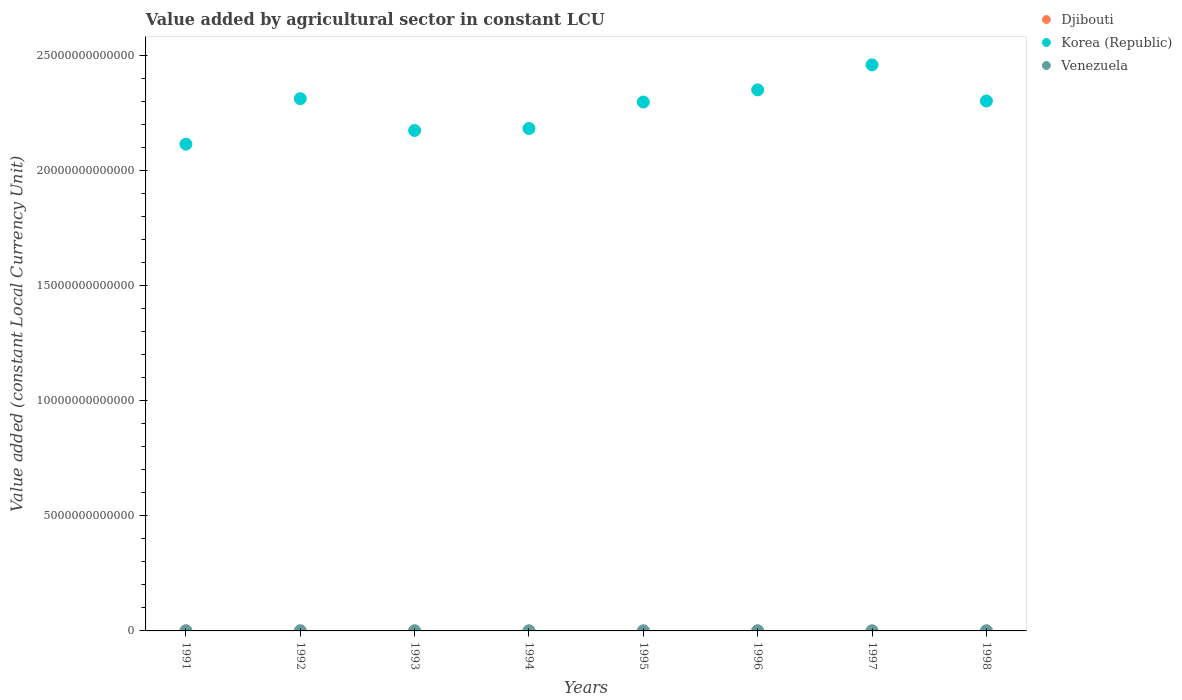Is the number of dotlines equal to the number of legend labels?
Your answer should be very brief. Yes. What is the value added by agricultural sector in Venezuela in 1991?
Provide a succinct answer. 1.82e+09. Across all years, what is the maximum value added by agricultural sector in Korea (Republic)?
Make the answer very short. 2.46e+13. Across all years, what is the minimum value added by agricultural sector in Djibouti?
Offer a very short reply. 1.95e+09. In which year was the value added by agricultural sector in Korea (Republic) maximum?
Provide a short and direct response. 1997. In which year was the value added by agricultural sector in Venezuela minimum?
Offer a terse response. 1991. What is the total value added by agricultural sector in Korea (Republic) in the graph?
Offer a very short reply. 1.82e+14. What is the difference between the value added by agricultural sector in Venezuela in 1995 and that in 1998?
Offer a very short reply. -6.92e+07. What is the difference between the value added by agricultural sector in Djibouti in 1998 and the value added by agricultural sector in Venezuela in 1991?
Offer a terse response. 1.99e+08. What is the average value added by agricultural sector in Venezuela per year?
Provide a short and direct response. 1.89e+09. In the year 1997, what is the difference between the value added by agricultural sector in Korea (Republic) and value added by agricultural sector in Venezuela?
Offer a very short reply. 2.46e+13. In how many years, is the value added by agricultural sector in Venezuela greater than 10000000000000 LCU?
Your response must be concise. 0. What is the ratio of the value added by agricultural sector in Korea (Republic) in 1996 to that in 1997?
Offer a terse response. 0.96. Is the difference between the value added by agricultural sector in Korea (Republic) in 1997 and 1998 greater than the difference between the value added by agricultural sector in Venezuela in 1997 and 1998?
Give a very brief answer. Yes. What is the difference between the highest and the second highest value added by agricultural sector in Djibouti?
Make the answer very short. 2.32e+07. What is the difference between the highest and the lowest value added by agricultural sector in Korea (Republic)?
Offer a very short reply. 3.44e+12. In how many years, is the value added by agricultural sector in Djibouti greater than the average value added by agricultural sector in Djibouti taken over all years?
Make the answer very short. 4. Is the sum of the value added by agricultural sector in Venezuela in 1996 and 1998 greater than the maximum value added by agricultural sector in Djibouti across all years?
Offer a terse response. Yes. Is it the case that in every year, the sum of the value added by agricultural sector in Korea (Republic) and value added by agricultural sector in Venezuela  is greater than the value added by agricultural sector in Djibouti?
Your answer should be compact. Yes. Is the value added by agricultural sector in Venezuela strictly greater than the value added by agricultural sector in Djibouti over the years?
Provide a succinct answer. No. How many dotlines are there?
Your response must be concise. 3. What is the difference between two consecutive major ticks on the Y-axis?
Provide a succinct answer. 5.00e+12. Are the values on the major ticks of Y-axis written in scientific E-notation?
Offer a very short reply. No. Where does the legend appear in the graph?
Your answer should be compact. Top right. How many legend labels are there?
Ensure brevity in your answer.  3. What is the title of the graph?
Offer a terse response. Value added by agricultural sector in constant LCU. Does "French Polynesia" appear as one of the legend labels in the graph?
Your answer should be compact. No. What is the label or title of the Y-axis?
Provide a succinct answer. Value added (constant Local Currency Unit). What is the Value added (constant Local Currency Unit) of Djibouti in 1991?
Your answer should be very brief. 2.14e+09. What is the Value added (constant Local Currency Unit) of Korea (Republic) in 1991?
Your answer should be compact. 2.11e+13. What is the Value added (constant Local Currency Unit) in Venezuela in 1991?
Provide a succinct answer. 1.82e+09. What is the Value added (constant Local Currency Unit) in Djibouti in 1992?
Make the answer very short. 2.23e+09. What is the Value added (constant Local Currency Unit) of Korea (Republic) in 1992?
Keep it short and to the point. 2.31e+13. What is the Value added (constant Local Currency Unit) in Venezuela in 1992?
Give a very brief answer. 1.86e+09. What is the Value added (constant Local Currency Unit) of Djibouti in 1993?
Offer a terse response. 2.25e+09. What is the Value added (constant Local Currency Unit) in Korea (Republic) in 1993?
Make the answer very short. 2.17e+13. What is the Value added (constant Local Currency Unit) in Venezuela in 1993?
Give a very brief answer. 1.91e+09. What is the Value added (constant Local Currency Unit) in Djibouti in 1994?
Your answer should be compact. 2.27e+09. What is the Value added (constant Local Currency Unit) in Korea (Republic) in 1994?
Your answer should be compact. 2.18e+13. What is the Value added (constant Local Currency Unit) of Venezuela in 1994?
Make the answer very short. 1.89e+09. What is the Value added (constant Local Currency Unit) of Djibouti in 1995?
Offer a terse response. 1.95e+09. What is the Value added (constant Local Currency Unit) in Korea (Republic) in 1995?
Your answer should be very brief. 2.30e+13. What is the Value added (constant Local Currency Unit) in Venezuela in 1995?
Give a very brief answer. 1.88e+09. What is the Value added (constant Local Currency Unit) of Djibouti in 1996?
Give a very brief answer. 2.01e+09. What is the Value added (constant Local Currency Unit) in Korea (Republic) in 1996?
Your answer should be very brief. 2.35e+13. What is the Value added (constant Local Currency Unit) of Venezuela in 1996?
Offer a very short reply. 1.92e+09. What is the Value added (constant Local Currency Unit) of Djibouti in 1997?
Your response must be concise. 2.00e+09. What is the Value added (constant Local Currency Unit) of Korea (Republic) in 1997?
Make the answer very short. 2.46e+13. What is the Value added (constant Local Currency Unit) of Venezuela in 1997?
Your answer should be compact. 1.89e+09. What is the Value added (constant Local Currency Unit) of Djibouti in 1998?
Your answer should be compact. 2.02e+09. What is the Value added (constant Local Currency Unit) of Korea (Republic) in 1998?
Make the answer very short. 2.30e+13. What is the Value added (constant Local Currency Unit) in Venezuela in 1998?
Make the answer very short. 1.95e+09. Across all years, what is the maximum Value added (constant Local Currency Unit) in Djibouti?
Offer a terse response. 2.27e+09. Across all years, what is the maximum Value added (constant Local Currency Unit) in Korea (Republic)?
Ensure brevity in your answer.  2.46e+13. Across all years, what is the maximum Value added (constant Local Currency Unit) in Venezuela?
Your answer should be very brief. 1.95e+09. Across all years, what is the minimum Value added (constant Local Currency Unit) of Djibouti?
Offer a terse response. 1.95e+09. Across all years, what is the minimum Value added (constant Local Currency Unit) in Korea (Republic)?
Your response must be concise. 2.11e+13. Across all years, what is the minimum Value added (constant Local Currency Unit) of Venezuela?
Your answer should be compact. 1.82e+09. What is the total Value added (constant Local Currency Unit) of Djibouti in the graph?
Your answer should be very brief. 1.69e+1. What is the total Value added (constant Local Currency Unit) in Korea (Republic) in the graph?
Ensure brevity in your answer.  1.82e+14. What is the total Value added (constant Local Currency Unit) of Venezuela in the graph?
Your answer should be compact. 1.51e+1. What is the difference between the Value added (constant Local Currency Unit) of Djibouti in 1991 and that in 1992?
Ensure brevity in your answer.  -8.37e+07. What is the difference between the Value added (constant Local Currency Unit) in Korea (Republic) in 1991 and that in 1992?
Offer a terse response. -1.98e+12. What is the difference between the Value added (constant Local Currency Unit) in Venezuela in 1991 and that in 1992?
Your answer should be compact. -3.68e+07. What is the difference between the Value added (constant Local Currency Unit) of Djibouti in 1991 and that in 1993?
Provide a succinct answer. -1.07e+08. What is the difference between the Value added (constant Local Currency Unit) of Korea (Republic) in 1991 and that in 1993?
Make the answer very short. -5.94e+11. What is the difference between the Value added (constant Local Currency Unit) of Venezuela in 1991 and that in 1993?
Your response must be concise. -9.30e+07. What is the difference between the Value added (constant Local Currency Unit) of Djibouti in 1991 and that in 1994?
Your answer should be very brief. -1.30e+08. What is the difference between the Value added (constant Local Currency Unit) in Korea (Republic) in 1991 and that in 1994?
Your answer should be very brief. -6.80e+11. What is the difference between the Value added (constant Local Currency Unit) of Venezuela in 1991 and that in 1994?
Your answer should be very brief. -7.19e+07. What is the difference between the Value added (constant Local Currency Unit) of Djibouti in 1991 and that in 1995?
Offer a very short reply. 1.98e+08. What is the difference between the Value added (constant Local Currency Unit) in Korea (Republic) in 1991 and that in 1995?
Offer a very short reply. -1.83e+12. What is the difference between the Value added (constant Local Currency Unit) of Venezuela in 1991 and that in 1995?
Keep it short and to the point. -6.16e+07. What is the difference between the Value added (constant Local Currency Unit) of Djibouti in 1991 and that in 1996?
Offer a terse response. 1.32e+08. What is the difference between the Value added (constant Local Currency Unit) in Korea (Republic) in 1991 and that in 1996?
Ensure brevity in your answer.  -2.36e+12. What is the difference between the Value added (constant Local Currency Unit) in Venezuela in 1991 and that in 1996?
Offer a very short reply. -9.87e+07. What is the difference between the Value added (constant Local Currency Unit) in Djibouti in 1991 and that in 1997?
Offer a terse response. 1.39e+08. What is the difference between the Value added (constant Local Currency Unit) of Korea (Republic) in 1991 and that in 1997?
Keep it short and to the point. -3.44e+12. What is the difference between the Value added (constant Local Currency Unit) in Venezuela in 1991 and that in 1997?
Your answer should be very brief. -6.49e+07. What is the difference between the Value added (constant Local Currency Unit) of Djibouti in 1991 and that in 1998?
Your answer should be very brief. 1.24e+08. What is the difference between the Value added (constant Local Currency Unit) of Korea (Republic) in 1991 and that in 1998?
Your answer should be compact. -1.88e+12. What is the difference between the Value added (constant Local Currency Unit) in Venezuela in 1991 and that in 1998?
Provide a succinct answer. -1.31e+08. What is the difference between the Value added (constant Local Currency Unit) in Djibouti in 1992 and that in 1993?
Offer a terse response. -2.35e+07. What is the difference between the Value added (constant Local Currency Unit) of Korea (Republic) in 1992 and that in 1993?
Your response must be concise. 1.38e+12. What is the difference between the Value added (constant Local Currency Unit) of Venezuela in 1992 and that in 1993?
Your answer should be very brief. -5.62e+07. What is the difference between the Value added (constant Local Currency Unit) in Djibouti in 1992 and that in 1994?
Give a very brief answer. -4.67e+07. What is the difference between the Value added (constant Local Currency Unit) in Korea (Republic) in 1992 and that in 1994?
Your response must be concise. 1.29e+12. What is the difference between the Value added (constant Local Currency Unit) in Venezuela in 1992 and that in 1994?
Your answer should be very brief. -3.51e+07. What is the difference between the Value added (constant Local Currency Unit) in Djibouti in 1992 and that in 1995?
Ensure brevity in your answer.  2.81e+08. What is the difference between the Value added (constant Local Currency Unit) in Korea (Republic) in 1992 and that in 1995?
Give a very brief answer. 1.46e+11. What is the difference between the Value added (constant Local Currency Unit) in Venezuela in 1992 and that in 1995?
Your response must be concise. -2.48e+07. What is the difference between the Value added (constant Local Currency Unit) of Djibouti in 1992 and that in 1996?
Keep it short and to the point. 2.16e+08. What is the difference between the Value added (constant Local Currency Unit) of Korea (Republic) in 1992 and that in 1996?
Your answer should be very brief. -3.83e+11. What is the difference between the Value added (constant Local Currency Unit) of Venezuela in 1992 and that in 1996?
Provide a succinct answer. -6.18e+07. What is the difference between the Value added (constant Local Currency Unit) in Djibouti in 1992 and that in 1997?
Your response must be concise. 2.23e+08. What is the difference between the Value added (constant Local Currency Unit) in Korea (Republic) in 1992 and that in 1997?
Give a very brief answer. -1.47e+12. What is the difference between the Value added (constant Local Currency Unit) in Venezuela in 1992 and that in 1997?
Keep it short and to the point. -2.81e+07. What is the difference between the Value added (constant Local Currency Unit) in Djibouti in 1992 and that in 1998?
Your answer should be very brief. 2.08e+08. What is the difference between the Value added (constant Local Currency Unit) of Korea (Republic) in 1992 and that in 1998?
Provide a succinct answer. 1.00e+11. What is the difference between the Value added (constant Local Currency Unit) in Venezuela in 1992 and that in 1998?
Make the answer very short. -9.40e+07. What is the difference between the Value added (constant Local Currency Unit) in Djibouti in 1993 and that in 1994?
Offer a terse response. -2.32e+07. What is the difference between the Value added (constant Local Currency Unit) of Korea (Republic) in 1993 and that in 1994?
Offer a very short reply. -8.64e+1. What is the difference between the Value added (constant Local Currency Unit) in Venezuela in 1993 and that in 1994?
Your answer should be compact. 2.11e+07. What is the difference between the Value added (constant Local Currency Unit) in Djibouti in 1993 and that in 1995?
Give a very brief answer. 3.05e+08. What is the difference between the Value added (constant Local Currency Unit) in Korea (Republic) in 1993 and that in 1995?
Offer a terse response. -1.24e+12. What is the difference between the Value added (constant Local Currency Unit) of Venezuela in 1993 and that in 1995?
Keep it short and to the point. 3.14e+07. What is the difference between the Value added (constant Local Currency Unit) in Djibouti in 1993 and that in 1996?
Your response must be concise. 2.40e+08. What is the difference between the Value added (constant Local Currency Unit) of Korea (Republic) in 1993 and that in 1996?
Provide a succinct answer. -1.76e+12. What is the difference between the Value added (constant Local Currency Unit) in Venezuela in 1993 and that in 1996?
Offer a terse response. -5.65e+06. What is the difference between the Value added (constant Local Currency Unit) of Djibouti in 1993 and that in 1997?
Your response must be concise. 2.47e+08. What is the difference between the Value added (constant Local Currency Unit) in Korea (Republic) in 1993 and that in 1997?
Give a very brief answer. -2.85e+12. What is the difference between the Value added (constant Local Currency Unit) of Venezuela in 1993 and that in 1997?
Provide a succinct answer. 2.81e+07. What is the difference between the Value added (constant Local Currency Unit) in Djibouti in 1993 and that in 1998?
Give a very brief answer. 2.31e+08. What is the difference between the Value added (constant Local Currency Unit) in Korea (Republic) in 1993 and that in 1998?
Make the answer very short. -1.28e+12. What is the difference between the Value added (constant Local Currency Unit) of Venezuela in 1993 and that in 1998?
Give a very brief answer. -3.78e+07. What is the difference between the Value added (constant Local Currency Unit) in Djibouti in 1994 and that in 1995?
Ensure brevity in your answer.  3.28e+08. What is the difference between the Value added (constant Local Currency Unit) in Korea (Republic) in 1994 and that in 1995?
Your answer should be very brief. -1.15e+12. What is the difference between the Value added (constant Local Currency Unit) of Venezuela in 1994 and that in 1995?
Offer a very short reply. 1.02e+07. What is the difference between the Value added (constant Local Currency Unit) of Djibouti in 1994 and that in 1996?
Your response must be concise. 2.63e+08. What is the difference between the Value added (constant Local Currency Unit) of Korea (Republic) in 1994 and that in 1996?
Give a very brief answer. -1.68e+12. What is the difference between the Value added (constant Local Currency Unit) of Venezuela in 1994 and that in 1996?
Your answer should be very brief. -2.68e+07. What is the difference between the Value added (constant Local Currency Unit) of Djibouti in 1994 and that in 1997?
Offer a very short reply. 2.70e+08. What is the difference between the Value added (constant Local Currency Unit) of Korea (Republic) in 1994 and that in 1997?
Your answer should be very brief. -2.76e+12. What is the difference between the Value added (constant Local Currency Unit) of Venezuela in 1994 and that in 1997?
Keep it short and to the point. 6.98e+06. What is the difference between the Value added (constant Local Currency Unit) of Djibouti in 1994 and that in 1998?
Ensure brevity in your answer.  2.54e+08. What is the difference between the Value added (constant Local Currency Unit) of Korea (Republic) in 1994 and that in 1998?
Provide a succinct answer. -1.19e+12. What is the difference between the Value added (constant Local Currency Unit) of Venezuela in 1994 and that in 1998?
Give a very brief answer. -5.89e+07. What is the difference between the Value added (constant Local Currency Unit) of Djibouti in 1995 and that in 1996?
Your answer should be very brief. -6.52e+07. What is the difference between the Value added (constant Local Currency Unit) of Korea (Republic) in 1995 and that in 1996?
Make the answer very short. -5.29e+11. What is the difference between the Value added (constant Local Currency Unit) in Venezuela in 1995 and that in 1996?
Provide a short and direct response. -3.70e+07. What is the difference between the Value added (constant Local Currency Unit) of Djibouti in 1995 and that in 1997?
Provide a short and direct response. -5.82e+07. What is the difference between the Value added (constant Local Currency Unit) of Korea (Republic) in 1995 and that in 1997?
Your response must be concise. -1.61e+12. What is the difference between the Value added (constant Local Currency Unit) of Venezuela in 1995 and that in 1997?
Ensure brevity in your answer.  -3.27e+06. What is the difference between the Value added (constant Local Currency Unit) of Djibouti in 1995 and that in 1998?
Keep it short and to the point. -7.37e+07. What is the difference between the Value added (constant Local Currency Unit) in Korea (Republic) in 1995 and that in 1998?
Keep it short and to the point. -4.61e+1. What is the difference between the Value added (constant Local Currency Unit) in Venezuela in 1995 and that in 1998?
Provide a short and direct response. -6.92e+07. What is the difference between the Value added (constant Local Currency Unit) in Djibouti in 1996 and that in 1997?
Give a very brief answer. 7.01e+06. What is the difference between the Value added (constant Local Currency Unit) of Korea (Republic) in 1996 and that in 1997?
Offer a terse response. -1.09e+12. What is the difference between the Value added (constant Local Currency Unit) in Venezuela in 1996 and that in 1997?
Provide a short and direct response. 3.38e+07. What is the difference between the Value added (constant Local Currency Unit) of Djibouti in 1996 and that in 1998?
Your answer should be compact. -8.45e+06. What is the difference between the Value added (constant Local Currency Unit) of Korea (Republic) in 1996 and that in 1998?
Make the answer very short. 4.83e+11. What is the difference between the Value added (constant Local Currency Unit) in Venezuela in 1996 and that in 1998?
Make the answer very short. -3.22e+07. What is the difference between the Value added (constant Local Currency Unit) of Djibouti in 1997 and that in 1998?
Provide a succinct answer. -1.55e+07. What is the difference between the Value added (constant Local Currency Unit) in Korea (Republic) in 1997 and that in 1998?
Provide a succinct answer. 1.57e+12. What is the difference between the Value added (constant Local Currency Unit) of Venezuela in 1997 and that in 1998?
Offer a very short reply. -6.59e+07. What is the difference between the Value added (constant Local Currency Unit) of Djibouti in 1991 and the Value added (constant Local Currency Unit) of Korea (Republic) in 1992?
Keep it short and to the point. -2.31e+13. What is the difference between the Value added (constant Local Currency Unit) in Djibouti in 1991 and the Value added (constant Local Currency Unit) in Venezuela in 1992?
Provide a succinct answer. 2.87e+08. What is the difference between the Value added (constant Local Currency Unit) of Korea (Republic) in 1991 and the Value added (constant Local Currency Unit) of Venezuela in 1992?
Give a very brief answer. 2.11e+13. What is the difference between the Value added (constant Local Currency Unit) in Djibouti in 1991 and the Value added (constant Local Currency Unit) in Korea (Republic) in 1993?
Make the answer very short. -2.17e+13. What is the difference between the Value added (constant Local Currency Unit) of Djibouti in 1991 and the Value added (constant Local Currency Unit) of Venezuela in 1993?
Give a very brief answer. 2.30e+08. What is the difference between the Value added (constant Local Currency Unit) of Korea (Republic) in 1991 and the Value added (constant Local Currency Unit) of Venezuela in 1993?
Your answer should be compact. 2.11e+13. What is the difference between the Value added (constant Local Currency Unit) in Djibouti in 1991 and the Value added (constant Local Currency Unit) in Korea (Republic) in 1994?
Provide a short and direct response. -2.18e+13. What is the difference between the Value added (constant Local Currency Unit) in Djibouti in 1991 and the Value added (constant Local Currency Unit) in Venezuela in 1994?
Provide a succinct answer. 2.51e+08. What is the difference between the Value added (constant Local Currency Unit) of Korea (Republic) in 1991 and the Value added (constant Local Currency Unit) of Venezuela in 1994?
Offer a very short reply. 2.11e+13. What is the difference between the Value added (constant Local Currency Unit) of Djibouti in 1991 and the Value added (constant Local Currency Unit) of Korea (Republic) in 1995?
Provide a short and direct response. -2.30e+13. What is the difference between the Value added (constant Local Currency Unit) of Djibouti in 1991 and the Value added (constant Local Currency Unit) of Venezuela in 1995?
Offer a very short reply. 2.62e+08. What is the difference between the Value added (constant Local Currency Unit) of Korea (Republic) in 1991 and the Value added (constant Local Currency Unit) of Venezuela in 1995?
Keep it short and to the point. 2.11e+13. What is the difference between the Value added (constant Local Currency Unit) of Djibouti in 1991 and the Value added (constant Local Currency Unit) of Korea (Republic) in 1996?
Make the answer very short. -2.35e+13. What is the difference between the Value added (constant Local Currency Unit) in Djibouti in 1991 and the Value added (constant Local Currency Unit) in Venezuela in 1996?
Ensure brevity in your answer.  2.25e+08. What is the difference between the Value added (constant Local Currency Unit) of Korea (Republic) in 1991 and the Value added (constant Local Currency Unit) of Venezuela in 1996?
Your answer should be very brief. 2.11e+13. What is the difference between the Value added (constant Local Currency Unit) in Djibouti in 1991 and the Value added (constant Local Currency Unit) in Korea (Republic) in 1997?
Provide a short and direct response. -2.46e+13. What is the difference between the Value added (constant Local Currency Unit) of Djibouti in 1991 and the Value added (constant Local Currency Unit) of Venezuela in 1997?
Ensure brevity in your answer.  2.58e+08. What is the difference between the Value added (constant Local Currency Unit) in Korea (Republic) in 1991 and the Value added (constant Local Currency Unit) in Venezuela in 1997?
Give a very brief answer. 2.11e+13. What is the difference between the Value added (constant Local Currency Unit) of Djibouti in 1991 and the Value added (constant Local Currency Unit) of Korea (Republic) in 1998?
Your response must be concise. -2.30e+13. What is the difference between the Value added (constant Local Currency Unit) in Djibouti in 1991 and the Value added (constant Local Currency Unit) in Venezuela in 1998?
Provide a short and direct response. 1.93e+08. What is the difference between the Value added (constant Local Currency Unit) in Korea (Republic) in 1991 and the Value added (constant Local Currency Unit) in Venezuela in 1998?
Your response must be concise. 2.11e+13. What is the difference between the Value added (constant Local Currency Unit) of Djibouti in 1992 and the Value added (constant Local Currency Unit) of Korea (Republic) in 1993?
Make the answer very short. -2.17e+13. What is the difference between the Value added (constant Local Currency Unit) of Djibouti in 1992 and the Value added (constant Local Currency Unit) of Venezuela in 1993?
Give a very brief answer. 3.14e+08. What is the difference between the Value added (constant Local Currency Unit) in Korea (Republic) in 1992 and the Value added (constant Local Currency Unit) in Venezuela in 1993?
Make the answer very short. 2.31e+13. What is the difference between the Value added (constant Local Currency Unit) in Djibouti in 1992 and the Value added (constant Local Currency Unit) in Korea (Republic) in 1994?
Give a very brief answer. -2.18e+13. What is the difference between the Value added (constant Local Currency Unit) in Djibouti in 1992 and the Value added (constant Local Currency Unit) in Venezuela in 1994?
Provide a short and direct response. 3.35e+08. What is the difference between the Value added (constant Local Currency Unit) in Korea (Republic) in 1992 and the Value added (constant Local Currency Unit) in Venezuela in 1994?
Ensure brevity in your answer.  2.31e+13. What is the difference between the Value added (constant Local Currency Unit) in Djibouti in 1992 and the Value added (constant Local Currency Unit) in Korea (Republic) in 1995?
Your answer should be very brief. -2.30e+13. What is the difference between the Value added (constant Local Currency Unit) of Djibouti in 1992 and the Value added (constant Local Currency Unit) of Venezuela in 1995?
Ensure brevity in your answer.  3.45e+08. What is the difference between the Value added (constant Local Currency Unit) in Korea (Republic) in 1992 and the Value added (constant Local Currency Unit) in Venezuela in 1995?
Your answer should be very brief. 2.31e+13. What is the difference between the Value added (constant Local Currency Unit) in Djibouti in 1992 and the Value added (constant Local Currency Unit) in Korea (Republic) in 1996?
Give a very brief answer. -2.35e+13. What is the difference between the Value added (constant Local Currency Unit) in Djibouti in 1992 and the Value added (constant Local Currency Unit) in Venezuela in 1996?
Offer a terse response. 3.08e+08. What is the difference between the Value added (constant Local Currency Unit) of Korea (Republic) in 1992 and the Value added (constant Local Currency Unit) of Venezuela in 1996?
Provide a succinct answer. 2.31e+13. What is the difference between the Value added (constant Local Currency Unit) of Djibouti in 1992 and the Value added (constant Local Currency Unit) of Korea (Republic) in 1997?
Provide a short and direct response. -2.46e+13. What is the difference between the Value added (constant Local Currency Unit) of Djibouti in 1992 and the Value added (constant Local Currency Unit) of Venezuela in 1997?
Give a very brief answer. 3.42e+08. What is the difference between the Value added (constant Local Currency Unit) of Korea (Republic) in 1992 and the Value added (constant Local Currency Unit) of Venezuela in 1997?
Provide a short and direct response. 2.31e+13. What is the difference between the Value added (constant Local Currency Unit) of Djibouti in 1992 and the Value added (constant Local Currency Unit) of Korea (Republic) in 1998?
Give a very brief answer. -2.30e+13. What is the difference between the Value added (constant Local Currency Unit) in Djibouti in 1992 and the Value added (constant Local Currency Unit) in Venezuela in 1998?
Your response must be concise. 2.76e+08. What is the difference between the Value added (constant Local Currency Unit) in Korea (Republic) in 1992 and the Value added (constant Local Currency Unit) in Venezuela in 1998?
Your answer should be compact. 2.31e+13. What is the difference between the Value added (constant Local Currency Unit) of Djibouti in 1993 and the Value added (constant Local Currency Unit) of Korea (Republic) in 1994?
Your answer should be compact. -2.18e+13. What is the difference between the Value added (constant Local Currency Unit) of Djibouti in 1993 and the Value added (constant Local Currency Unit) of Venezuela in 1994?
Your answer should be compact. 3.59e+08. What is the difference between the Value added (constant Local Currency Unit) of Korea (Republic) in 1993 and the Value added (constant Local Currency Unit) of Venezuela in 1994?
Provide a succinct answer. 2.17e+13. What is the difference between the Value added (constant Local Currency Unit) of Djibouti in 1993 and the Value added (constant Local Currency Unit) of Korea (Republic) in 1995?
Make the answer very short. -2.30e+13. What is the difference between the Value added (constant Local Currency Unit) of Djibouti in 1993 and the Value added (constant Local Currency Unit) of Venezuela in 1995?
Give a very brief answer. 3.69e+08. What is the difference between the Value added (constant Local Currency Unit) of Korea (Republic) in 1993 and the Value added (constant Local Currency Unit) of Venezuela in 1995?
Offer a terse response. 2.17e+13. What is the difference between the Value added (constant Local Currency Unit) in Djibouti in 1993 and the Value added (constant Local Currency Unit) in Korea (Republic) in 1996?
Provide a short and direct response. -2.35e+13. What is the difference between the Value added (constant Local Currency Unit) in Djibouti in 1993 and the Value added (constant Local Currency Unit) in Venezuela in 1996?
Give a very brief answer. 3.32e+08. What is the difference between the Value added (constant Local Currency Unit) of Korea (Republic) in 1993 and the Value added (constant Local Currency Unit) of Venezuela in 1996?
Offer a terse response. 2.17e+13. What is the difference between the Value added (constant Local Currency Unit) in Djibouti in 1993 and the Value added (constant Local Currency Unit) in Korea (Republic) in 1997?
Provide a succinct answer. -2.46e+13. What is the difference between the Value added (constant Local Currency Unit) of Djibouti in 1993 and the Value added (constant Local Currency Unit) of Venezuela in 1997?
Offer a terse response. 3.66e+08. What is the difference between the Value added (constant Local Currency Unit) in Korea (Republic) in 1993 and the Value added (constant Local Currency Unit) in Venezuela in 1997?
Your answer should be very brief. 2.17e+13. What is the difference between the Value added (constant Local Currency Unit) in Djibouti in 1993 and the Value added (constant Local Currency Unit) in Korea (Republic) in 1998?
Give a very brief answer. -2.30e+13. What is the difference between the Value added (constant Local Currency Unit) of Djibouti in 1993 and the Value added (constant Local Currency Unit) of Venezuela in 1998?
Give a very brief answer. 3.00e+08. What is the difference between the Value added (constant Local Currency Unit) in Korea (Republic) in 1993 and the Value added (constant Local Currency Unit) in Venezuela in 1998?
Provide a short and direct response. 2.17e+13. What is the difference between the Value added (constant Local Currency Unit) of Djibouti in 1994 and the Value added (constant Local Currency Unit) of Korea (Republic) in 1995?
Give a very brief answer. -2.30e+13. What is the difference between the Value added (constant Local Currency Unit) of Djibouti in 1994 and the Value added (constant Local Currency Unit) of Venezuela in 1995?
Your response must be concise. 3.92e+08. What is the difference between the Value added (constant Local Currency Unit) of Korea (Republic) in 1994 and the Value added (constant Local Currency Unit) of Venezuela in 1995?
Offer a very short reply. 2.18e+13. What is the difference between the Value added (constant Local Currency Unit) of Djibouti in 1994 and the Value added (constant Local Currency Unit) of Korea (Republic) in 1996?
Your answer should be very brief. -2.35e+13. What is the difference between the Value added (constant Local Currency Unit) in Djibouti in 1994 and the Value added (constant Local Currency Unit) in Venezuela in 1996?
Make the answer very short. 3.55e+08. What is the difference between the Value added (constant Local Currency Unit) of Korea (Republic) in 1994 and the Value added (constant Local Currency Unit) of Venezuela in 1996?
Give a very brief answer. 2.18e+13. What is the difference between the Value added (constant Local Currency Unit) of Djibouti in 1994 and the Value added (constant Local Currency Unit) of Korea (Republic) in 1997?
Make the answer very short. -2.46e+13. What is the difference between the Value added (constant Local Currency Unit) in Djibouti in 1994 and the Value added (constant Local Currency Unit) in Venezuela in 1997?
Your answer should be compact. 3.89e+08. What is the difference between the Value added (constant Local Currency Unit) of Korea (Republic) in 1994 and the Value added (constant Local Currency Unit) of Venezuela in 1997?
Ensure brevity in your answer.  2.18e+13. What is the difference between the Value added (constant Local Currency Unit) in Djibouti in 1994 and the Value added (constant Local Currency Unit) in Korea (Republic) in 1998?
Your answer should be very brief. -2.30e+13. What is the difference between the Value added (constant Local Currency Unit) in Djibouti in 1994 and the Value added (constant Local Currency Unit) in Venezuela in 1998?
Make the answer very short. 3.23e+08. What is the difference between the Value added (constant Local Currency Unit) of Korea (Republic) in 1994 and the Value added (constant Local Currency Unit) of Venezuela in 1998?
Make the answer very short. 2.18e+13. What is the difference between the Value added (constant Local Currency Unit) of Djibouti in 1995 and the Value added (constant Local Currency Unit) of Korea (Republic) in 1996?
Ensure brevity in your answer.  -2.35e+13. What is the difference between the Value added (constant Local Currency Unit) of Djibouti in 1995 and the Value added (constant Local Currency Unit) of Venezuela in 1996?
Keep it short and to the point. 2.71e+07. What is the difference between the Value added (constant Local Currency Unit) in Korea (Republic) in 1995 and the Value added (constant Local Currency Unit) in Venezuela in 1996?
Provide a short and direct response. 2.30e+13. What is the difference between the Value added (constant Local Currency Unit) in Djibouti in 1995 and the Value added (constant Local Currency Unit) in Korea (Republic) in 1997?
Keep it short and to the point. -2.46e+13. What is the difference between the Value added (constant Local Currency Unit) of Djibouti in 1995 and the Value added (constant Local Currency Unit) of Venezuela in 1997?
Make the answer very short. 6.09e+07. What is the difference between the Value added (constant Local Currency Unit) of Korea (Republic) in 1995 and the Value added (constant Local Currency Unit) of Venezuela in 1997?
Your answer should be compact. 2.30e+13. What is the difference between the Value added (constant Local Currency Unit) of Djibouti in 1995 and the Value added (constant Local Currency Unit) of Korea (Republic) in 1998?
Provide a short and direct response. -2.30e+13. What is the difference between the Value added (constant Local Currency Unit) of Djibouti in 1995 and the Value added (constant Local Currency Unit) of Venezuela in 1998?
Provide a succinct answer. -5.04e+06. What is the difference between the Value added (constant Local Currency Unit) in Korea (Republic) in 1995 and the Value added (constant Local Currency Unit) in Venezuela in 1998?
Provide a short and direct response. 2.30e+13. What is the difference between the Value added (constant Local Currency Unit) in Djibouti in 1996 and the Value added (constant Local Currency Unit) in Korea (Republic) in 1997?
Offer a very short reply. -2.46e+13. What is the difference between the Value added (constant Local Currency Unit) of Djibouti in 1996 and the Value added (constant Local Currency Unit) of Venezuela in 1997?
Make the answer very short. 1.26e+08. What is the difference between the Value added (constant Local Currency Unit) in Korea (Republic) in 1996 and the Value added (constant Local Currency Unit) in Venezuela in 1997?
Keep it short and to the point. 2.35e+13. What is the difference between the Value added (constant Local Currency Unit) of Djibouti in 1996 and the Value added (constant Local Currency Unit) of Korea (Republic) in 1998?
Offer a terse response. -2.30e+13. What is the difference between the Value added (constant Local Currency Unit) of Djibouti in 1996 and the Value added (constant Local Currency Unit) of Venezuela in 1998?
Keep it short and to the point. 6.02e+07. What is the difference between the Value added (constant Local Currency Unit) in Korea (Republic) in 1996 and the Value added (constant Local Currency Unit) in Venezuela in 1998?
Your answer should be compact. 2.35e+13. What is the difference between the Value added (constant Local Currency Unit) of Djibouti in 1997 and the Value added (constant Local Currency Unit) of Korea (Republic) in 1998?
Make the answer very short. -2.30e+13. What is the difference between the Value added (constant Local Currency Unit) of Djibouti in 1997 and the Value added (constant Local Currency Unit) of Venezuela in 1998?
Offer a very short reply. 5.31e+07. What is the difference between the Value added (constant Local Currency Unit) of Korea (Republic) in 1997 and the Value added (constant Local Currency Unit) of Venezuela in 1998?
Offer a terse response. 2.46e+13. What is the average Value added (constant Local Currency Unit) in Djibouti per year?
Ensure brevity in your answer.  2.11e+09. What is the average Value added (constant Local Currency Unit) in Korea (Republic) per year?
Keep it short and to the point. 2.27e+13. What is the average Value added (constant Local Currency Unit) of Venezuela per year?
Provide a short and direct response. 1.89e+09. In the year 1991, what is the difference between the Value added (constant Local Currency Unit) of Djibouti and Value added (constant Local Currency Unit) of Korea (Republic)?
Provide a short and direct response. -2.11e+13. In the year 1991, what is the difference between the Value added (constant Local Currency Unit) in Djibouti and Value added (constant Local Currency Unit) in Venezuela?
Ensure brevity in your answer.  3.23e+08. In the year 1991, what is the difference between the Value added (constant Local Currency Unit) in Korea (Republic) and Value added (constant Local Currency Unit) in Venezuela?
Ensure brevity in your answer.  2.11e+13. In the year 1992, what is the difference between the Value added (constant Local Currency Unit) of Djibouti and Value added (constant Local Currency Unit) of Korea (Republic)?
Offer a terse response. -2.31e+13. In the year 1992, what is the difference between the Value added (constant Local Currency Unit) in Djibouti and Value added (constant Local Currency Unit) in Venezuela?
Give a very brief answer. 3.70e+08. In the year 1992, what is the difference between the Value added (constant Local Currency Unit) of Korea (Republic) and Value added (constant Local Currency Unit) of Venezuela?
Keep it short and to the point. 2.31e+13. In the year 1993, what is the difference between the Value added (constant Local Currency Unit) in Djibouti and Value added (constant Local Currency Unit) in Korea (Republic)?
Make the answer very short. -2.17e+13. In the year 1993, what is the difference between the Value added (constant Local Currency Unit) of Djibouti and Value added (constant Local Currency Unit) of Venezuela?
Keep it short and to the point. 3.38e+08. In the year 1993, what is the difference between the Value added (constant Local Currency Unit) of Korea (Republic) and Value added (constant Local Currency Unit) of Venezuela?
Keep it short and to the point. 2.17e+13. In the year 1994, what is the difference between the Value added (constant Local Currency Unit) of Djibouti and Value added (constant Local Currency Unit) of Korea (Republic)?
Provide a short and direct response. -2.18e+13. In the year 1994, what is the difference between the Value added (constant Local Currency Unit) in Djibouti and Value added (constant Local Currency Unit) in Venezuela?
Your response must be concise. 3.82e+08. In the year 1994, what is the difference between the Value added (constant Local Currency Unit) of Korea (Republic) and Value added (constant Local Currency Unit) of Venezuela?
Offer a terse response. 2.18e+13. In the year 1995, what is the difference between the Value added (constant Local Currency Unit) in Djibouti and Value added (constant Local Currency Unit) in Korea (Republic)?
Give a very brief answer. -2.30e+13. In the year 1995, what is the difference between the Value added (constant Local Currency Unit) in Djibouti and Value added (constant Local Currency Unit) in Venezuela?
Ensure brevity in your answer.  6.41e+07. In the year 1995, what is the difference between the Value added (constant Local Currency Unit) in Korea (Republic) and Value added (constant Local Currency Unit) in Venezuela?
Provide a short and direct response. 2.30e+13. In the year 1996, what is the difference between the Value added (constant Local Currency Unit) of Djibouti and Value added (constant Local Currency Unit) of Korea (Republic)?
Ensure brevity in your answer.  -2.35e+13. In the year 1996, what is the difference between the Value added (constant Local Currency Unit) of Djibouti and Value added (constant Local Currency Unit) of Venezuela?
Ensure brevity in your answer.  9.23e+07. In the year 1996, what is the difference between the Value added (constant Local Currency Unit) of Korea (Republic) and Value added (constant Local Currency Unit) of Venezuela?
Provide a succinct answer. 2.35e+13. In the year 1997, what is the difference between the Value added (constant Local Currency Unit) of Djibouti and Value added (constant Local Currency Unit) of Korea (Republic)?
Your response must be concise. -2.46e+13. In the year 1997, what is the difference between the Value added (constant Local Currency Unit) in Djibouti and Value added (constant Local Currency Unit) in Venezuela?
Your answer should be compact. 1.19e+08. In the year 1997, what is the difference between the Value added (constant Local Currency Unit) in Korea (Republic) and Value added (constant Local Currency Unit) in Venezuela?
Make the answer very short. 2.46e+13. In the year 1998, what is the difference between the Value added (constant Local Currency Unit) in Djibouti and Value added (constant Local Currency Unit) in Korea (Republic)?
Provide a short and direct response. -2.30e+13. In the year 1998, what is the difference between the Value added (constant Local Currency Unit) of Djibouti and Value added (constant Local Currency Unit) of Venezuela?
Provide a succinct answer. 6.86e+07. In the year 1998, what is the difference between the Value added (constant Local Currency Unit) in Korea (Republic) and Value added (constant Local Currency Unit) in Venezuela?
Offer a terse response. 2.30e+13. What is the ratio of the Value added (constant Local Currency Unit) in Djibouti in 1991 to that in 1992?
Your answer should be very brief. 0.96. What is the ratio of the Value added (constant Local Currency Unit) of Korea (Republic) in 1991 to that in 1992?
Your answer should be compact. 0.91. What is the ratio of the Value added (constant Local Currency Unit) in Venezuela in 1991 to that in 1992?
Provide a succinct answer. 0.98. What is the ratio of the Value added (constant Local Currency Unit) of Djibouti in 1991 to that in 1993?
Give a very brief answer. 0.95. What is the ratio of the Value added (constant Local Currency Unit) in Korea (Republic) in 1991 to that in 1993?
Your answer should be very brief. 0.97. What is the ratio of the Value added (constant Local Currency Unit) in Venezuela in 1991 to that in 1993?
Provide a succinct answer. 0.95. What is the ratio of the Value added (constant Local Currency Unit) of Djibouti in 1991 to that in 1994?
Provide a succinct answer. 0.94. What is the ratio of the Value added (constant Local Currency Unit) in Korea (Republic) in 1991 to that in 1994?
Provide a short and direct response. 0.97. What is the ratio of the Value added (constant Local Currency Unit) in Venezuela in 1991 to that in 1994?
Your answer should be compact. 0.96. What is the ratio of the Value added (constant Local Currency Unit) in Djibouti in 1991 to that in 1995?
Your answer should be compact. 1.1. What is the ratio of the Value added (constant Local Currency Unit) of Korea (Republic) in 1991 to that in 1995?
Your response must be concise. 0.92. What is the ratio of the Value added (constant Local Currency Unit) of Venezuela in 1991 to that in 1995?
Ensure brevity in your answer.  0.97. What is the ratio of the Value added (constant Local Currency Unit) in Djibouti in 1991 to that in 1996?
Provide a succinct answer. 1.07. What is the ratio of the Value added (constant Local Currency Unit) in Korea (Republic) in 1991 to that in 1996?
Your answer should be very brief. 0.9. What is the ratio of the Value added (constant Local Currency Unit) in Venezuela in 1991 to that in 1996?
Offer a terse response. 0.95. What is the ratio of the Value added (constant Local Currency Unit) in Djibouti in 1991 to that in 1997?
Keep it short and to the point. 1.07. What is the ratio of the Value added (constant Local Currency Unit) in Korea (Republic) in 1991 to that in 1997?
Your response must be concise. 0.86. What is the ratio of the Value added (constant Local Currency Unit) of Venezuela in 1991 to that in 1997?
Provide a short and direct response. 0.97. What is the ratio of the Value added (constant Local Currency Unit) in Djibouti in 1991 to that in 1998?
Keep it short and to the point. 1.06. What is the ratio of the Value added (constant Local Currency Unit) in Korea (Republic) in 1991 to that in 1998?
Your answer should be very brief. 0.92. What is the ratio of the Value added (constant Local Currency Unit) in Venezuela in 1991 to that in 1998?
Offer a very short reply. 0.93. What is the ratio of the Value added (constant Local Currency Unit) in Korea (Republic) in 1992 to that in 1993?
Provide a short and direct response. 1.06. What is the ratio of the Value added (constant Local Currency Unit) in Venezuela in 1992 to that in 1993?
Keep it short and to the point. 0.97. What is the ratio of the Value added (constant Local Currency Unit) of Djibouti in 1992 to that in 1994?
Your response must be concise. 0.98. What is the ratio of the Value added (constant Local Currency Unit) in Korea (Republic) in 1992 to that in 1994?
Your answer should be very brief. 1.06. What is the ratio of the Value added (constant Local Currency Unit) in Venezuela in 1992 to that in 1994?
Keep it short and to the point. 0.98. What is the ratio of the Value added (constant Local Currency Unit) of Djibouti in 1992 to that in 1995?
Offer a very short reply. 1.14. What is the ratio of the Value added (constant Local Currency Unit) of Korea (Republic) in 1992 to that in 1995?
Give a very brief answer. 1.01. What is the ratio of the Value added (constant Local Currency Unit) in Venezuela in 1992 to that in 1995?
Give a very brief answer. 0.99. What is the ratio of the Value added (constant Local Currency Unit) of Djibouti in 1992 to that in 1996?
Your answer should be very brief. 1.11. What is the ratio of the Value added (constant Local Currency Unit) of Korea (Republic) in 1992 to that in 1996?
Your answer should be very brief. 0.98. What is the ratio of the Value added (constant Local Currency Unit) of Venezuela in 1992 to that in 1996?
Give a very brief answer. 0.97. What is the ratio of the Value added (constant Local Currency Unit) of Djibouti in 1992 to that in 1997?
Give a very brief answer. 1.11. What is the ratio of the Value added (constant Local Currency Unit) of Korea (Republic) in 1992 to that in 1997?
Your response must be concise. 0.94. What is the ratio of the Value added (constant Local Currency Unit) of Venezuela in 1992 to that in 1997?
Make the answer very short. 0.99. What is the ratio of the Value added (constant Local Currency Unit) in Djibouti in 1992 to that in 1998?
Provide a short and direct response. 1.1. What is the ratio of the Value added (constant Local Currency Unit) of Venezuela in 1992 to that in 1998?
Make the answer very short. 0.95. What is the ratio of the Value added (constant Local Currency Unit) in Korea (Republic) in 1993 to that in 1994?
Keep it short and to the point. 1. What is the ratio of the Value added (constant Local Currency Unit) in Venezuela in 1993 to that in 1994?
Offer a very short reply. 1.01. What is the ratio of the Value added (constant Local Currency Unit) of Djibouti in 1993 to that in 1995?
Ensure brevity in your answer.  1.16. What is the ratio of the Value added (constant Local Currency Unit) of Korea (Republic) in 1993 to that in 1995?
Make the answer very short. 0.95. What is the ratio of the Value added (constant Local Currency Unit) of Venezuela in 1993 to that in 1995?
Your answer should be compact. 1.02. What is the ratio of the Value added (constant Local Currency Unit) of Djibouti in 1993 to that in 1996?
Provide a succinct answer. 1.12. What is the ratio of the Value added (constant Local Currency Unit) of Korea (Republic) in 1993 to that in 1996?
Provide a succinct answer. 0.92. What is the ratio of the Value added (constant Local Currency Unit) of Djibouti in 1993 to that in 1997?
Your answer should be very brief. 1.12. What is the ratio of the Value added (constant Local Currency Unit) in Korea (Republic) in 1993 to that in 1997?
Your answer should be compact. 0.88. What is the ratio of the Value added (constant Local Currency Unit) of Venezuela in 1993 to that in 1997?
Keep it short and to the point. 1.01. What is the ratio of the Value added (constant Local Currency Unit) in Djibouti in 1993 to that in 1998?
Your response must be concise. 1.11. What is the ratio of the Value added (constant Local Currency Unit) of Korea (Republic) in 1993 to that in 1998?
Give a very brief answer. 0.94. What is the ratio of the Value added (constant Local Currency Unit) in Venezuela in 1993 to that in 1998?
Make the answer very short. 0.98. What is the ratio of the Value added (constant Local Currency Unit) of Djibouti in 1994 to that in 1995?
Provide a short and direct response. 1.17. What is the ratio of the Value added (constant Local Currency Unit) in Venezuela in 1994 to that in 1995?
Ensure brevity in your answer.  1.01. What is the ratio of the Value added (constant Local Currency Unit) of Djibouti in 1994 to that in 1996?
Keep it short and to the point. 1.13. What is the ratio of the Value added (constant Local Currency Unit) in Venezuela in 1994 to that in 1996?
Offer a very short reply. 0.99. What is the ratio of the Value added (constant Local Currency Unit) of Djibouti in 1994 to that in 1997?
Ensure brevity in your answer.  1.13. What is the ratio of the Value added (constant Local Currency Unit) in Korea (Republic) in 1994 to that in 1997?
Your answer should be compact. 0.89. What is the ratio of the Value added (constant Local Currency Unit) of Djibouti in 1994 to that in 1998?
Keep it short and to the point. 1.13. What is the ratio of the Value added (constant Local Currency Unit) of Korea (Republic) in 1994 to that in 1998?
Give a very brief answer. 0.95. What is the ratio of the Value added (constant Local Currency Unit) of Venezuela in 1994 to that in 1998?
Ensure brevity in your answer.  0.97. What is the ratio of the Value added (constant Local Currency Unit) in Djibouti in 1995 to that in 1996?
Keep it short and to the point. 0.97. What is the ratio of the Value added (constant Local Currency Unit) in Korea (Republic) in 1995 to that in 1996?
Your response must be concise. 0.98. What is the ratio of the Value added (constant Local Currency Unit) of Venezuela in 1995 to that in 1996?
Offer a terse response. 0.98. What is the ratio of the Value added (constant Local Currency Unit) of Korea (Republic) in 1995 to that in 1997?
Offer a terse response. 0.93. What is the ratio of the Value added (constant Local Currency Unit) in Djibouti in 1995 to that in 1998?
Ensure brevity in your answer.  0.96. What is the ratio of the Value added (constant Local Currency Unit) in Korea (Republic) in 1995 to that in 1998?
Your answer should be compact. 1. What is the ratio of the Value added (constant Local Currency Unit) of Venezuela in 1995 to that in 1998?
Ensure brevity in your answer.  0.96. What is the ratio of the Value added (constant Local Currency Unit) of Korea (Republic) in 1996 to that in 1997?
Offer a terse response. 0.96. What is the ratio of the Value added (constant Local Currency Unit) in Venezuela in 1996 to that in 1997?
Make the answer very short. 1.02. What is the ratio of the Value added (constant Local Currency Unit) in Korea (Republic) in 1996 to that in 1998?
Offer a terse response. 1.02. What is the ratio of the Value added (constant Local Currency Unit) of Venezuela in 1996 to that in 1998?
Offer a very short reply. 0.98. What is the ratio of the Value added (constant Local Currency Unit) in Djibouti in 1997 to that in 1998?
Offer a very short reply. 0.99. What is the ratio of the Value added (constant Local Currency Unit) in Korea (Republic) in 1997 to that in 1998?
Your response must be concise. 1.07. What is the ratio of the Value added (constant Local Currency Unit) of Venezuela in 1997 to that in 1998?
Your answer should be compact. 0.97. What is the difference between the highest and the second highest Value added (constant Local Currency Unit) in Djibouti?
Ensure brevity in your answer.  2.32e+07. What is the difference between the highest and the second highest Value added (constant Local Currency Unit) in Korea (Republic)?
Offer a terse response. 1.09e+12. What is the difference between the highest and the second highest Value added (constant Local Currency Unit) of Venezuela?
Make the answer very short. 3.22e+07. What is the difference between the highest and the lowest Value added (constant Local Currency Unit) of Djibouti?
Offer a very short reply. 3.28e+08. What is the difference between the highest and the lowest Value added (constant Local Currency Unit) of Korea (Republic)?
Ensure brevity in your answer.  3.44e+12. What is the difference between the highest and the lowest Value added (constant Local Currency Unit) of Venezuela?
Your answer should be very brief. 1.31e+08. 